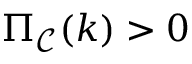Convert formula to latex. <formula><loc_0><loc_0><loc_500><loc_500>\Pi _ { \mathcal { C } } ( k ) > 0</formula> 